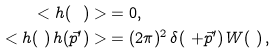Convert formula to latex. <formula><loc_0><loc_0><loc_500><loc_500>< h ( \ ) > & = 0 , \\ < h ( \ ) \, h ( \vec { p } ^ { \prime } ) > & = ( 2 \pi ) ^ { 2 } \, \delta ( \ + \vec { p } ^ { \prime } ) \, W ( \ ) \, ,</formula> 